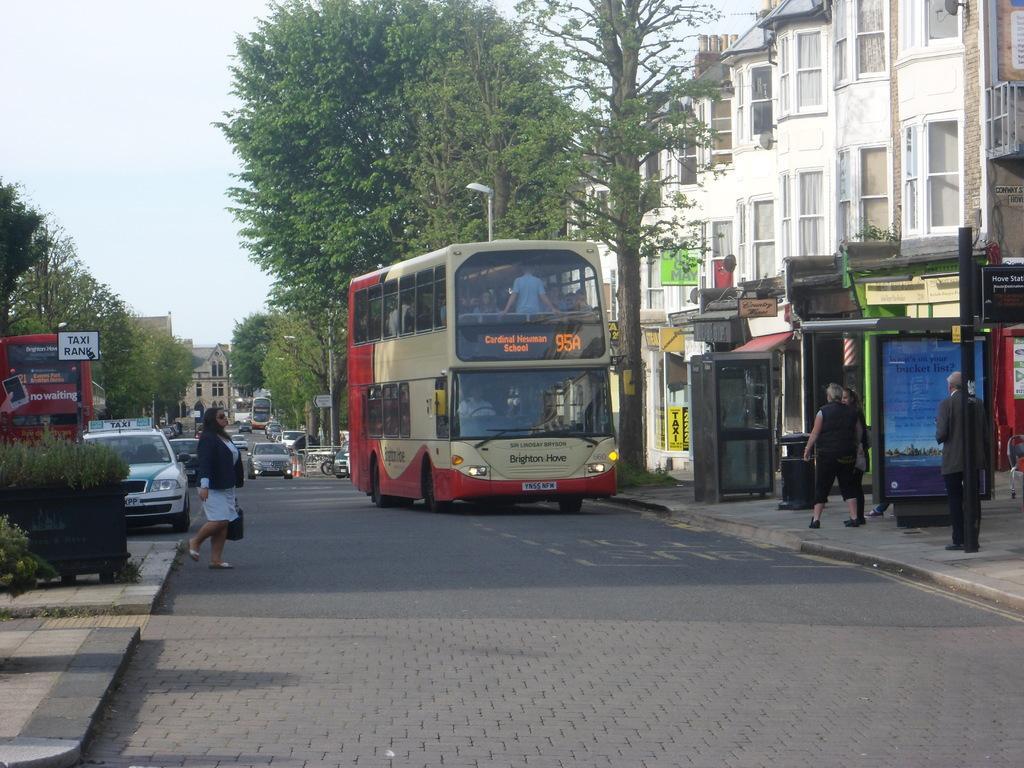In one or two sentences, can you explain what this image depicts? There is a road. On the road there are many vehicles. On the sides there are sidewalks. On the left side there are trees and board. Also there are plants in a box. And there is a lady walking. On the right side there are few people on the sidewalk. There are buildings with windows. Also there are trees and light poles. In the background there is sky. 